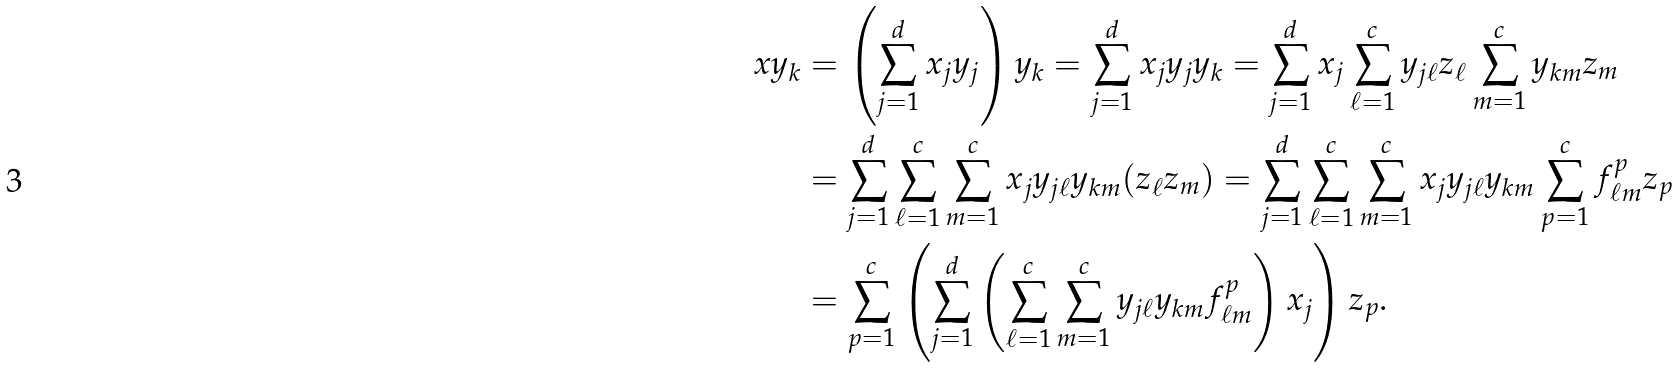<formula> <loc_0><loc_0><loc_500><loc_500>x y _ { k } & = \left ( \sum _ { j = 1 } ^ { d } x _ { j } y _ { j } \right ) y _ { k } = \sum _ { j = 1 } ^ { d } x _ { j } y _ { j } y _ { k } = \sum _ { j = 1 } ^ { d } x _ { j } \sum _ { \ell = 1 } ^ { c } y _ { j \ell } z _ { \ell } \sum _ { m = 1 } ^ { c } y _ { k m } z _ { m } \\ & = \sum _ { j = 1 } ^ { d } \sum _ { \ell = 1 } ^ { c } \sum _ { m = 1 } ^ { c } x _ { j } y _ { j \ell } y _ { k m } ( z _ { \ell } z _ { m } ) = \sum _ { j = 1 } ^ { d } \sum _ { \ell = 1 } ^ { c } \sum _ { m = 1 } ^ { c } x _ { j } y _ { j \ell } y _ { k m } \sum _ { p = 1 } ^ { c } f _ { \ell m } ^ { p } z _ { p } \\ & = \sum _ { p = 1 } ^ { c } \left ( \sum _ { j = 1 } ^ { d } \left ( \sum _ { \ell = 1 } ^ { c } \sum _ { m = 1 } ^ { c } y _ { j \ell } y _ { k m } f _ { \ell m } ^ { p } \right ) x _ { j } \right ) z _ { p } .</formula> 